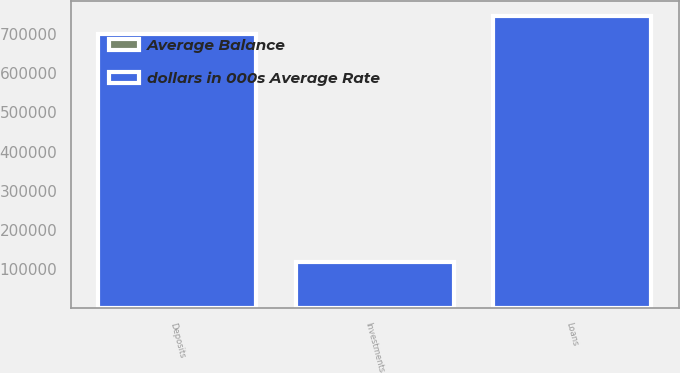<chart> <loc_0><loc_0><loc_500><loc_500><stacked_bar_chart><ecel><fcel>Loans<fcel>Investments<fcel>Deposits<nl><fcel>dollars in 000s Average Rate<fcel>746387<fcel>117350<fcel>700707<nl><fcel>Average Balance<fcel>6.8<fcel>5.25<fcel>4.59<nl></chart> 